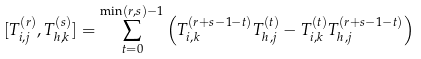<formula> <loc_0><loc_0><loc_500><loc_500>[ T _ { i , j } ^ { ( r ) } , T _ { h , k } ^ { ( s ) } ] = \sum _ { t = 0 } ^ { \min ( r , s ) - 1 } \left ( T _ { i , k } ^ { ( r + s - 1 - t ) } T _ { h , j } ^ { ( t ) } - T _ { i , k } ^ { ( t ) } T _ { h , j } ^ { ( r + s - 1 - t ) } \right )</formula> 